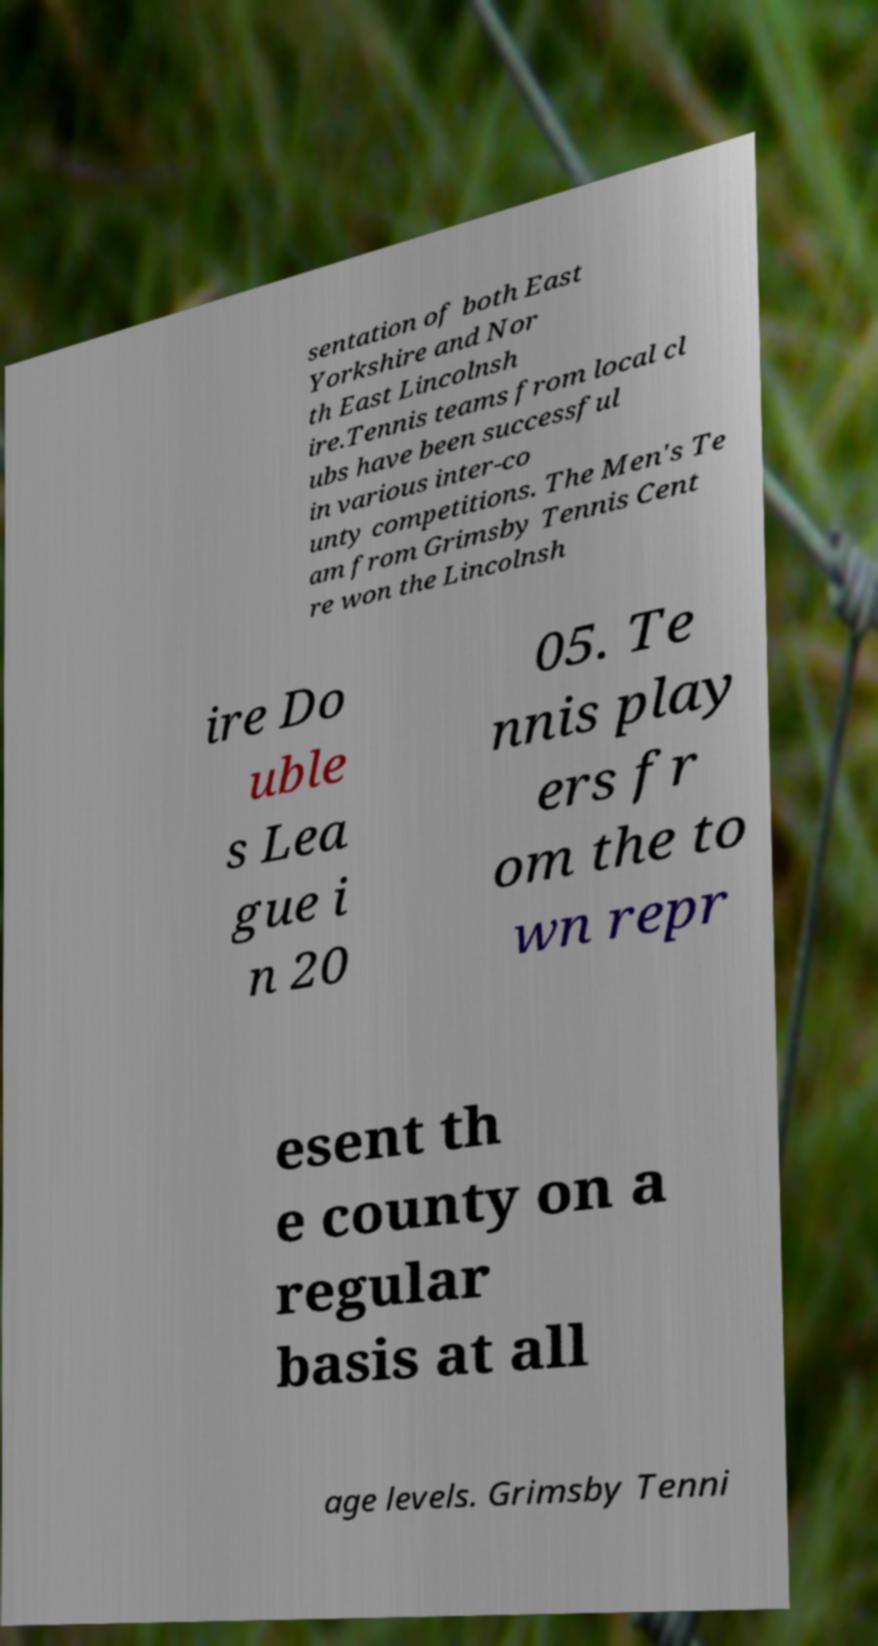Can you read and provide the text displayed in the image?This photo seems to have some interesting text. Can you extract and type it out for me? sentation of both East Yorkshire and Nor th East Lincolnsh ire.Tennis teams from local cl ubs have been successful in various inter-co unty competitions. The Men's Te am from Grimsby Tennis Cent re won the Lincolnsh ire Do uble s Lea gue i n 20 05. Te nnis play ers fr om the to wn repr esent th e county on a regular basis at all age levels. Grimsby Tenni 